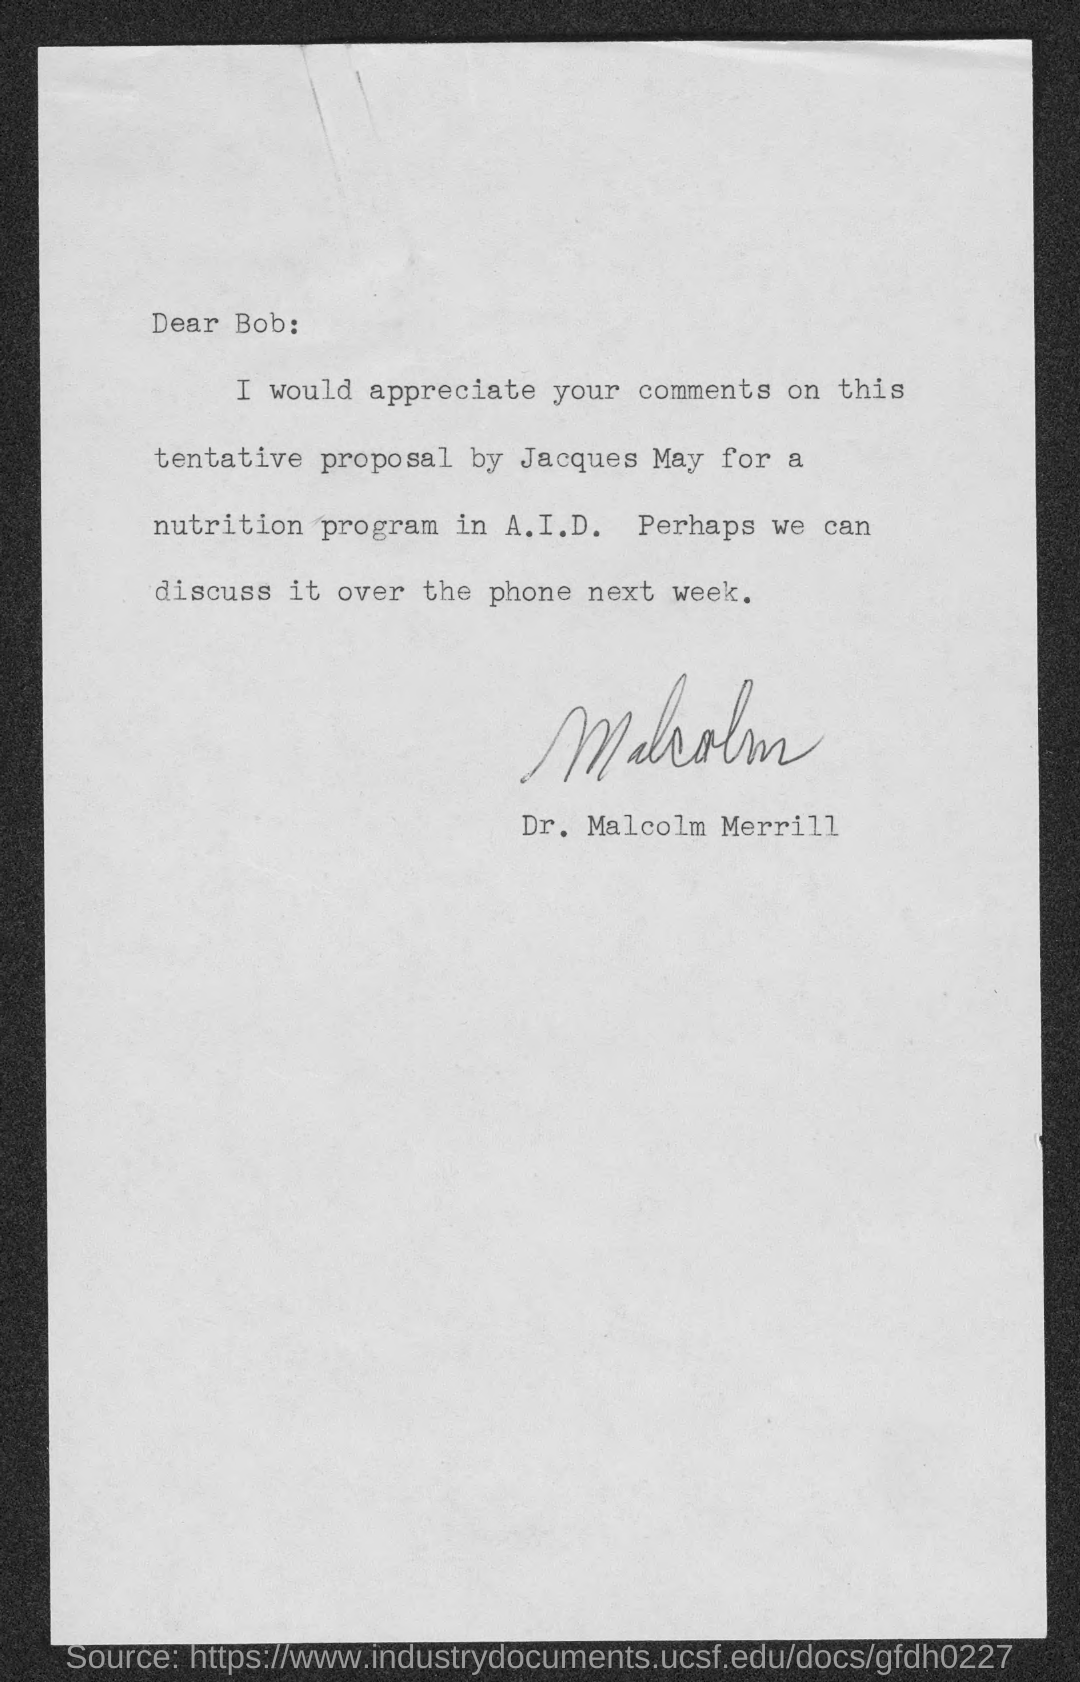Identify some key points in this picture. The sender of the letter is Dr. Malcolm Merrill. Jacques May made the proposal. 